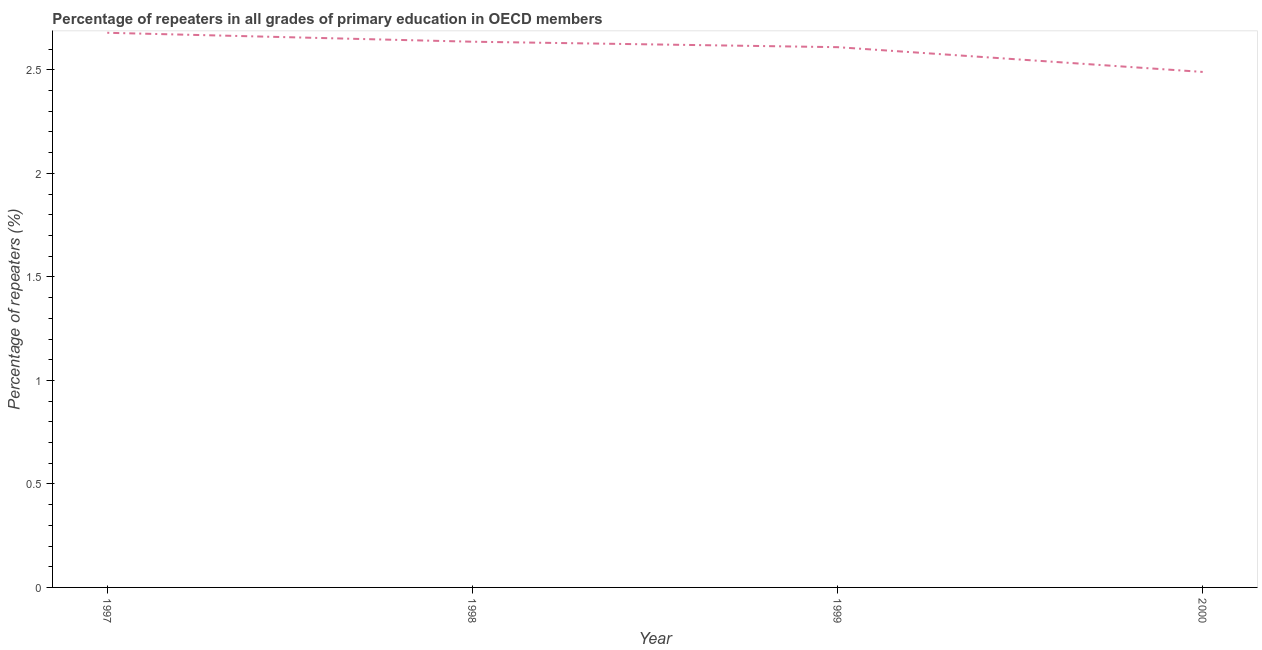What is the percentage of repeaters in primary education in 1999?
Give a very brief answer. 2.61. Across all years, what is the maximum percentage of repeaters in primary education?
Ensure brevity in your answer.  2.68. Across all years, what is the minimum percentage of repeaters in primary education?
Ensure brevity in your answer.  2.49. In which year was the percentage of repeaters in primary education maximum?
Make the answer very short. 1997. In which year was the percentage of repeaters in primary education minimum?
Your response must be concise. 2000. What is the sum of the percentage of repeaters in primary education?
Keep it short and to the point. 10.41. What is the difference between the percentage of repeaters in primary education in 1997 and 2000?
Provide a short and direct response. 0.19. What is the average percentage of repeaters in primary education per year?
Your answer should be very brief. 2.6. What is the median percentage of repeaters in primary education?
Give a very brief answer. 2.62. In how many years, is the percentage of repeaters in primary education greater than 0.5 %?
Provide a short and direct response. 4. What is the ratio of the percentage of repeaters in primary education in 1998 to that in 1999?
Give a very brief answer. 1.01. Is the difference between the percentage of repeaters in primary education in 1997 and 1999 greater than the difference between any two years?
Your answer should be very brief. No. What is the difference between the highest and the second highest percentage of repeaters in primary education?
Provide a succinct answer. 0.04. What is the difference between the highest and the lowest percentage of repeaters in primary education?
Provide a succinct answer. 0.19. Does the percentage of repeaters in primary education monotonically increase over the years?
Provide a succinct answer. No. Are the values on the major ticks of Y-axis written in scientific E-notation?
Ensure brevity in your answer.  No. Does the graph contain any zero values?
Offer a terse response. No. Does the graph contain grids?
Offer a terse response. No. What is the title of the graph?
Give a very brief answer. Percentage of repeaters in all grades of primary education in OECD members. What is the label or title of the Y-axis?
Give a very brief answer. Percentage of repeaters (%). What is the Percentage of repeaters (%) in 1997?
Offer a terse response. 2.68. What is the Percentage of repeaters (%) of 1998?
Your answer should be very brief. 2.64. What is the Percentage of repeaters (%) in 1999?
Provide a short and direct response. 2.61. What is the Percentage of repeaters (%) in 2000?
Your response must be concise. 2.49. What is the difference between the Percentage of repeaters (%) in 1997 and 1998?
Give a very brief answer. 0.04. What is the difference between the Percentage of repeaters (%) in 1997 and 1999?
Your response must be concise. 0.07. What is the difference between the Percentage of repeaters (%) in 1997 and 2000?
Offer a very short reply. 0.19. What is the difference between the Percentage of repeaters (%) in 1998 and 1999?
Offer a terse response. 0.03. What is the difference between the Percentage of repeaters (%) in 1998 and 2000?
Provide a succinct answer. 0.15. What is the difference between the Percentage of repeaters (%) in 1999 and 2000?
Give a very brief answer. 0.12. What is the ratio of the Percentage of repeaters (%) in 1997 to that in 1998?
Provide a succinct answer. 1.02. What is the ratio of the Percentage of repeaters (%) in 1997 to that in 1999?
Your answer should be very brief. 1.03. What is the ratio of the Percentage of repeaters (%) in 1997 to that in 2000?
Keep it short and to the point. 1.08. What is the ratio of the Percentage of repeaters (%) in 1998 to that in 2000?
Provide a succinct answer. 1.06. What is the ratio of the Percentage of repeaters (%) in 1999 to that in 2000?
Offer a very short reply. 1.05. 